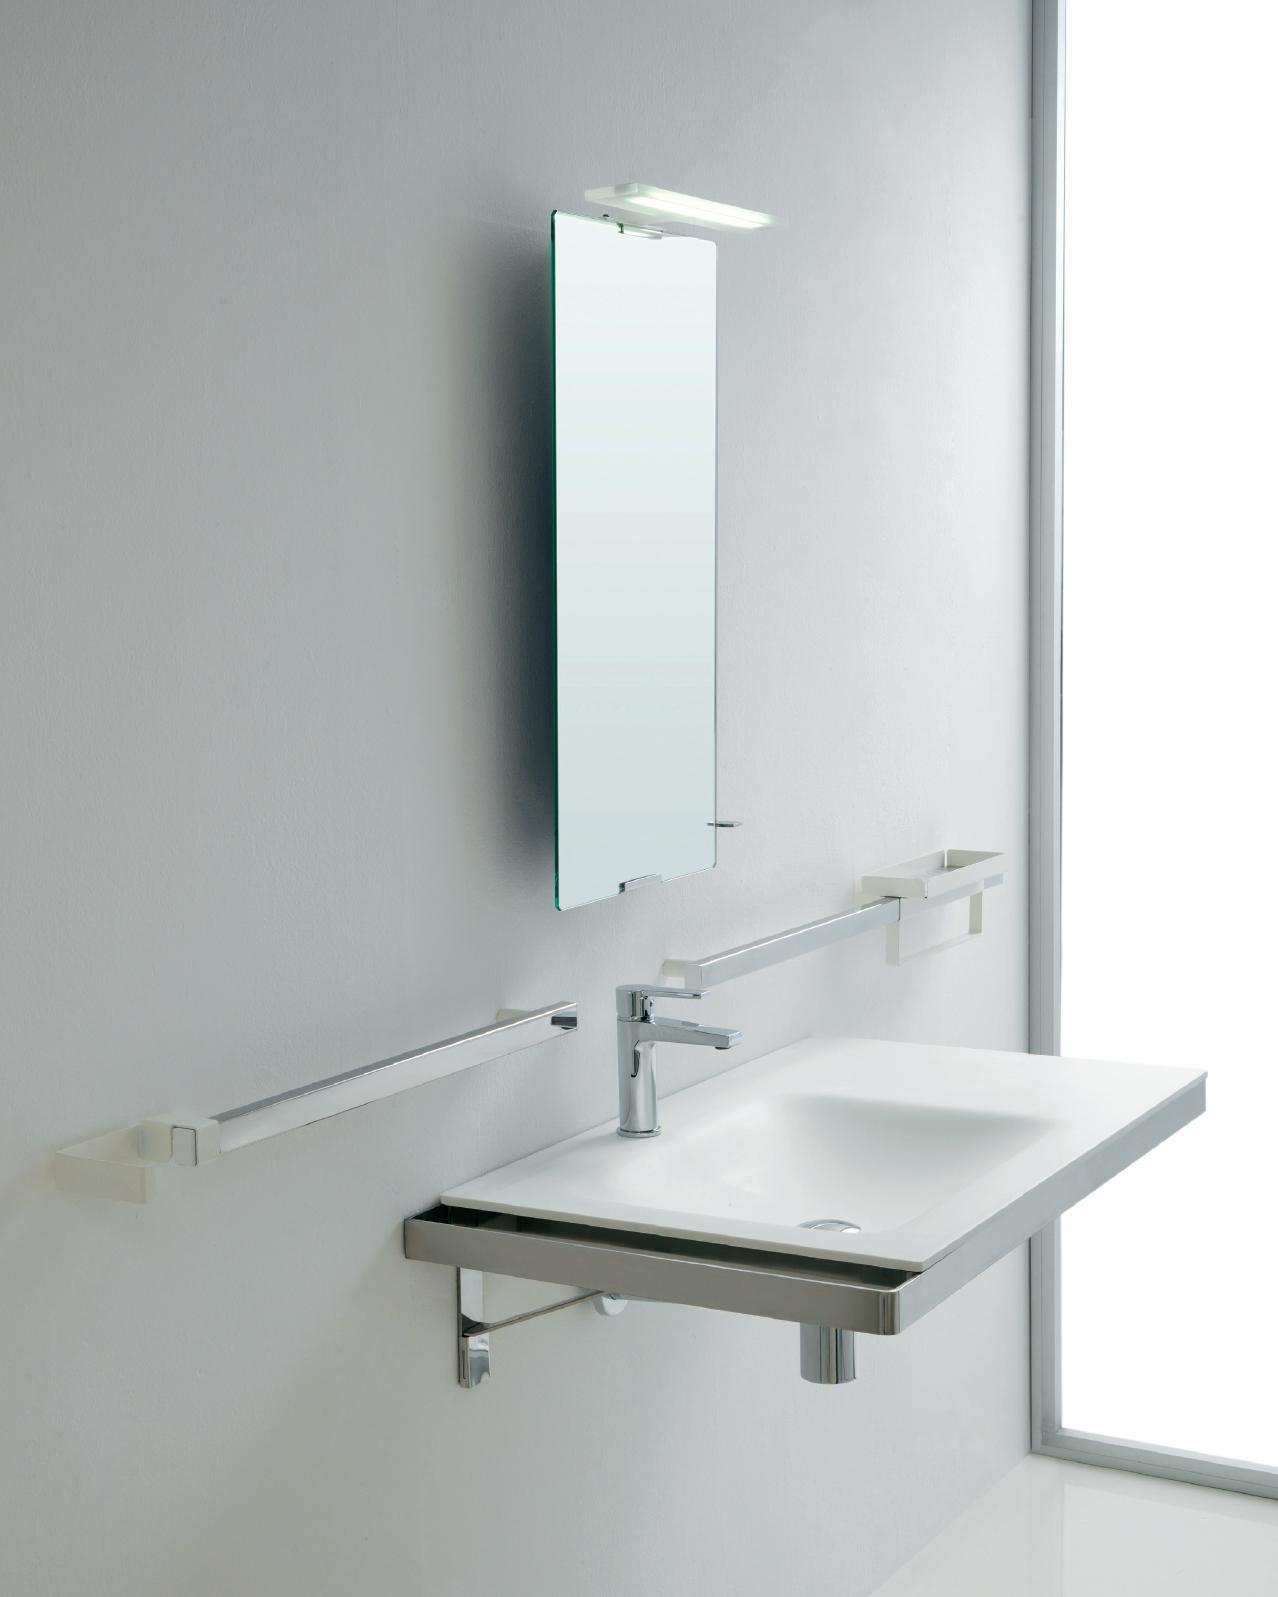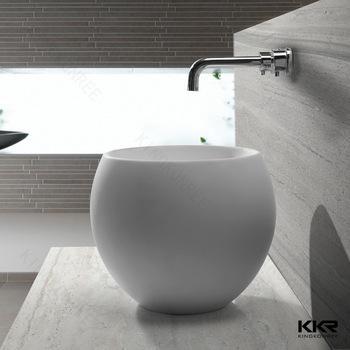The first image is the image on the left, the second image is the image on the right. Given the left and right images, does the statement "All sinks shown mount to the wall and have a rounded inset basin without a separate counter." hold true? Answer yes or no. No. The first image is the image on the left, the second image is the image on the right. Assess this claim about the two images: "A rectangular mirror hangs over  a wash basin in one of the images.". Correct or not? Answer yes or no. Yes. 